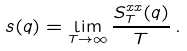<formula> <loc_0><loc_0><loc_500><loc_500>s ( q ) = \lim _ { T \to \infty } \frac { S ^ { x x } _ { T } ( q ) } { T } \, .</formula> 